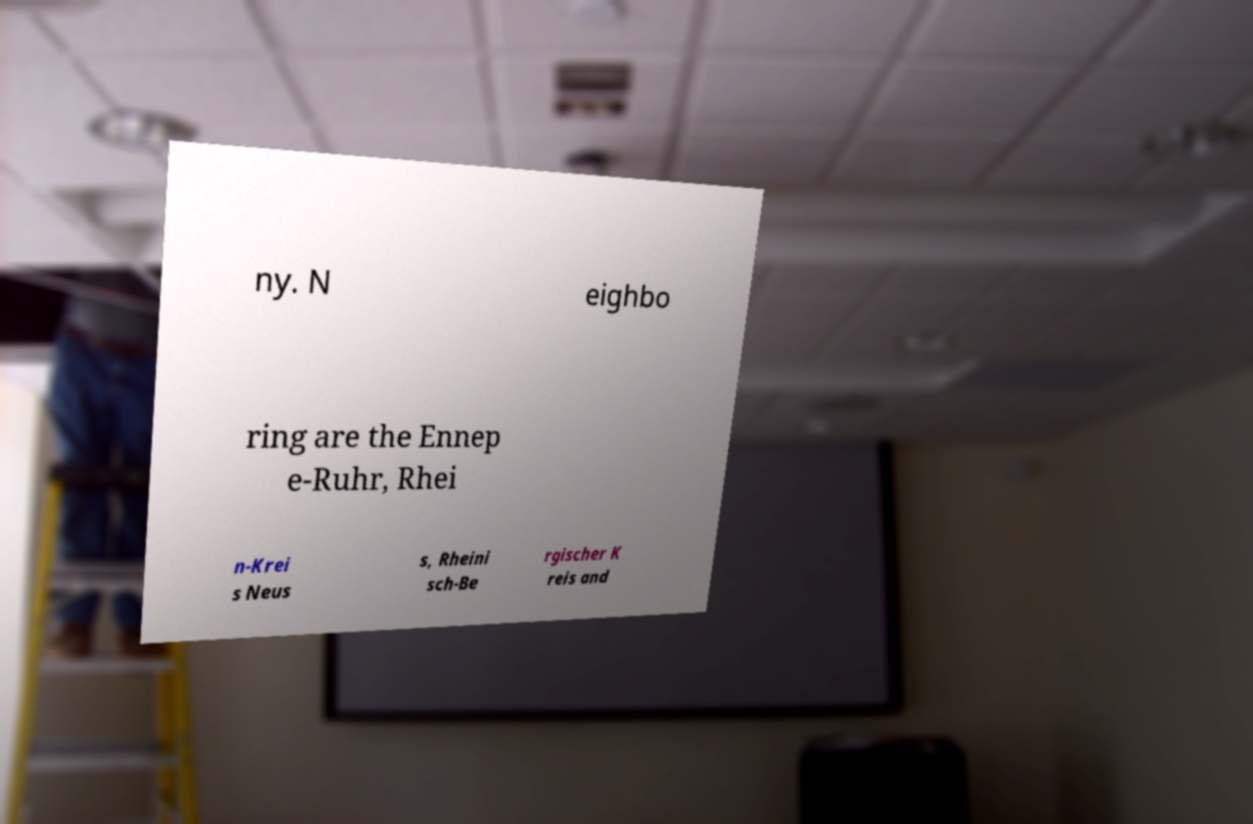Can you accurately transcribe the text from the provided image for me? ny. N eighbo ring are the Ennep e-Ruhr, Rhei n-Krei s Neus s, Rheini sch-Be rgischer K reis and 